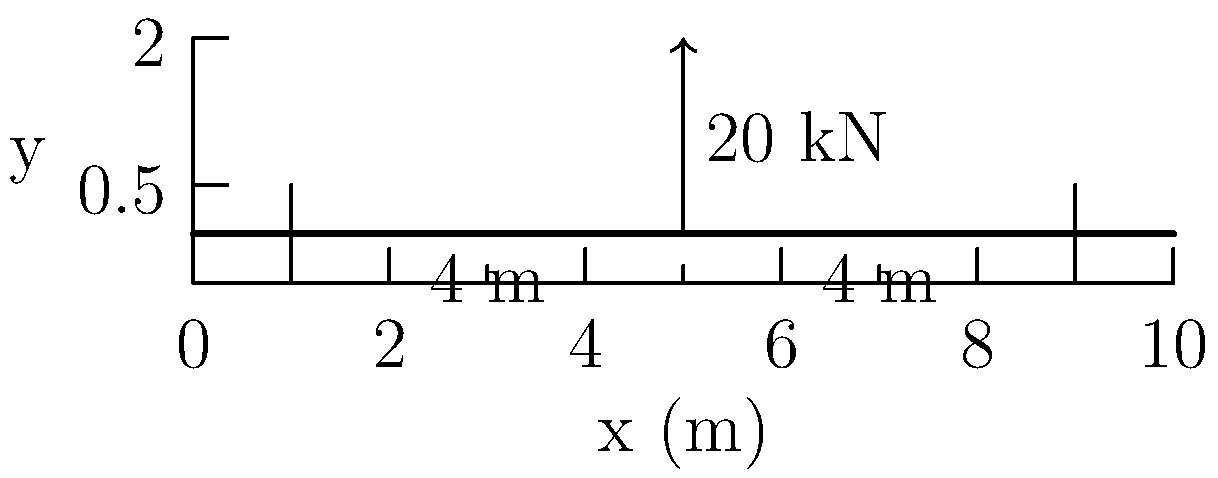As an IT administrator troubleshooting clipboard-related issues, you encounter a civil engineering diagram on a user's clipboard. The diagram shows a simply supported beam with a 20 kN point load at its center. The beam span is 8 m, with supports at 1 m from each end. Calculate the maximum shear force and bending moment in the beam. Let's approach this step-by-step:

1) First, we need to calculate the reactions at the supports:
   Due to symmetry, each support will bear half of the total load.
   $R_A = R_B = 20 \text{ kN} / 2 = 10 \text{ kN}$

2) Now, let's calculate the shear force:
   - From left support to the load: $V = 10 \text{ kN}$
   - From the load to right support: $V = -10 \text{ kN}$
   The maximum shear force is 10 kN (absolute value).

3) For the bending moment:
   - It increases linearly from 0 at the left support to a maximum at the center load.
   - The maximum bending moment occurs under the point load.
   - We can calculate it as: $M_{max} = R_A \times 4 \text{ m} = 10 \text{ kN} \times 4 \text{ m} = 40 \text{ kN}\cdot\text{m}$

4) Verify:
   - The bending moment at the center can also be calculated as:
     $M_{max} = \frac{PL}{4} = \frac{20 \text{ kN} \times 8 \text{ m}}{4} = 40 \text{ kN}\cdot\text{m}$

Therefore, the maximum shear force is 10 kN and the maximum bending moment is 40 kN·m.
Answer: Maximum shear force: 10 kN; Maximum bending moment: 40 kN·m 